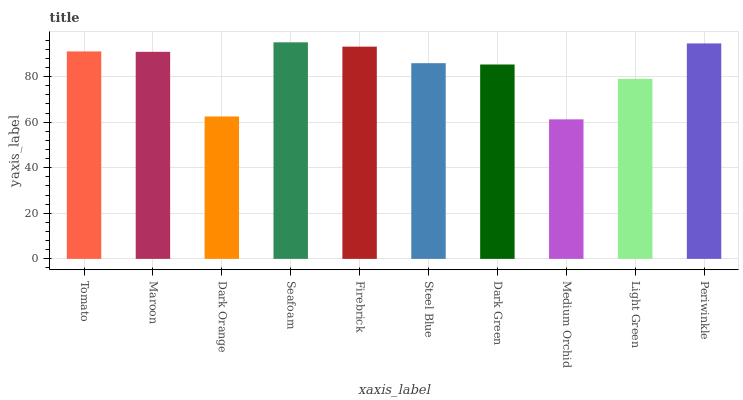Is Medium Orchid the minimum?
Answer yes or no. Yes. Is Seafoam the maximum?
Answer yes or no. Yes. Is Maroon the minimum?
Answer yes or no. No. Is Maroon the maximum?
Answer yes or no. No. Is Tomato greater than Maroon?
Answer yes or no. Yes. Is Maroon less than Tomato?
Answer yes or no. Yes. Is Maroon greater than Tomato?
Answer yes or no. No. Is Tomato less than Maroon?
Answer yes or no. No. Is Maroon the high median?
Answer yes or no. Yes. Is Steel Blue the low median?
Answer yes or no. Yes. Is Dark Green the high median?
Answer yes or no. No. Is Medium Orchid the low median?
Answer yes or no. No. 